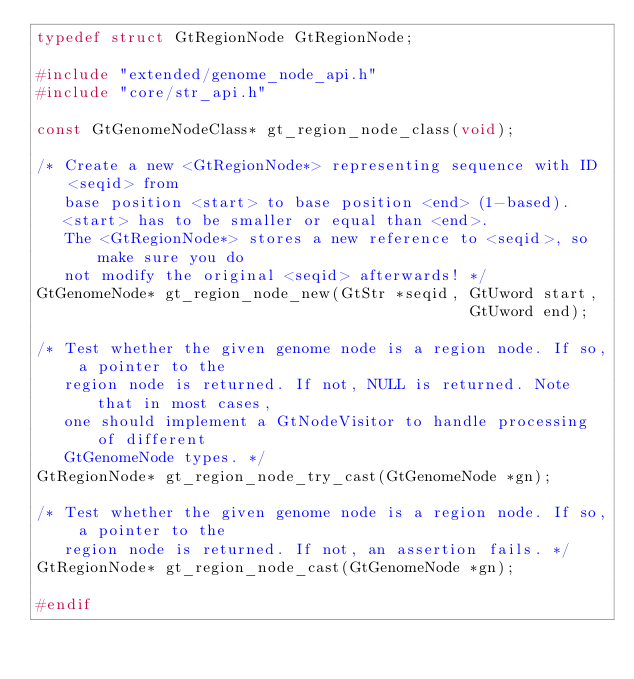Convert code to text. <code><loc_0><loc_0><loc_500><loc_500><_C_>typedef struct GtRegionNode GtRegionNode;

#include "extended/genome_node_api.h"
#include "core/str_api.h"

const GtGenomeNodeClass* gt_region_node_class(void);

/* Create a new <GtRegionNode*> representing sequence with ID <seqid> from
   base position <start> to base position <end> (1-based).
   <start> has to be smaller or equal than <end>.
   The <GtRegionNode*> stores a new reference to <seqid>, so make sure you do
   not modify the original <seqid> afterwards! */
GtGenomeNode* gt_region_node_new(GtStr *seqid, GtUword start,
                                               GtUword end);

/* Test whether the given genome node is a region node. If so, a pointer to the
   region node is returned. If not, NULL is returned. Note that in most cases,
   one should implement a GtNodeVisitor to handle processing of different
   GtGenomeNode types. */
GtRegionNode* gt_region_node_try_cast(GtGenomeNode *gn);

/* Test whether the given genome node is a region node. If so, a pointer to the
   region node is returned. If not, an assertion fails. */
GtRegionNode* gt_region_node_cast(GtGenomeNode *gn);

#endif
</code> 